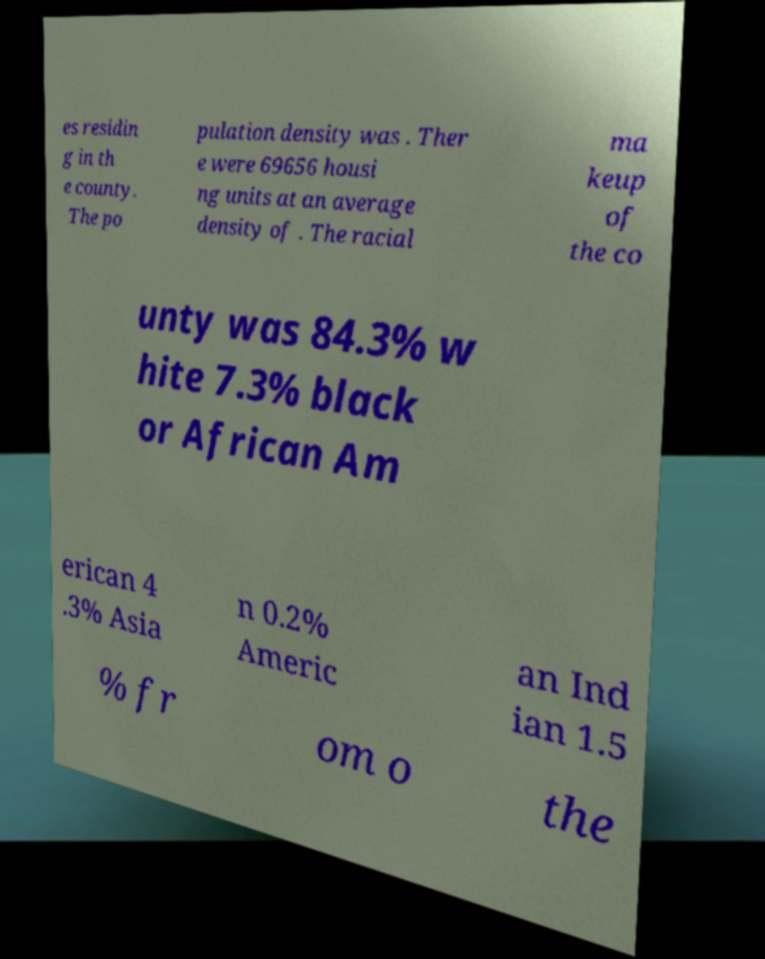Could you extract and type out the text from this image? es residin g in th e county. The po pulation density was . Ther e were 69656 housi ng units at an average density of . The racial ma keup of the co unty was 84.3% w hite 7.3% black or African Am erican 4 .3% Asia n 0.2% Americ an Ind ian 1.5 % fr om o the 